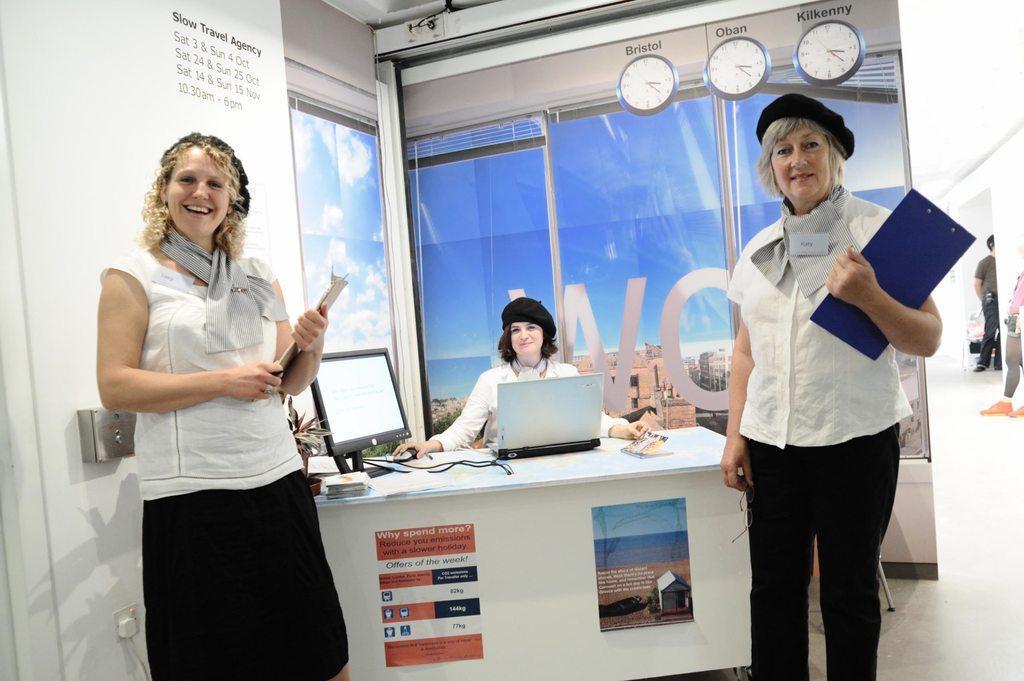Describe this image in one or two sentences. In this image there are two persons standing and holding wooden pads, and there is a person sitting on the chair, there is a laptop, monitor, book, napkin, cables on the table, and in the background there is a banner, two persons standing. 